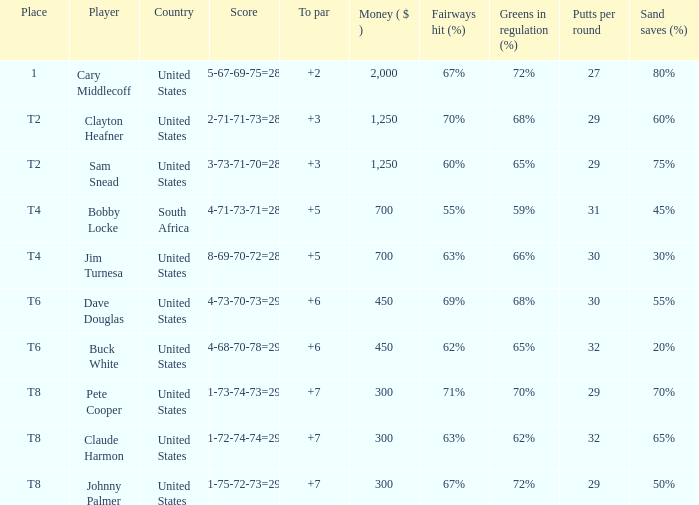What is Claude Harmon's Place? T8. 